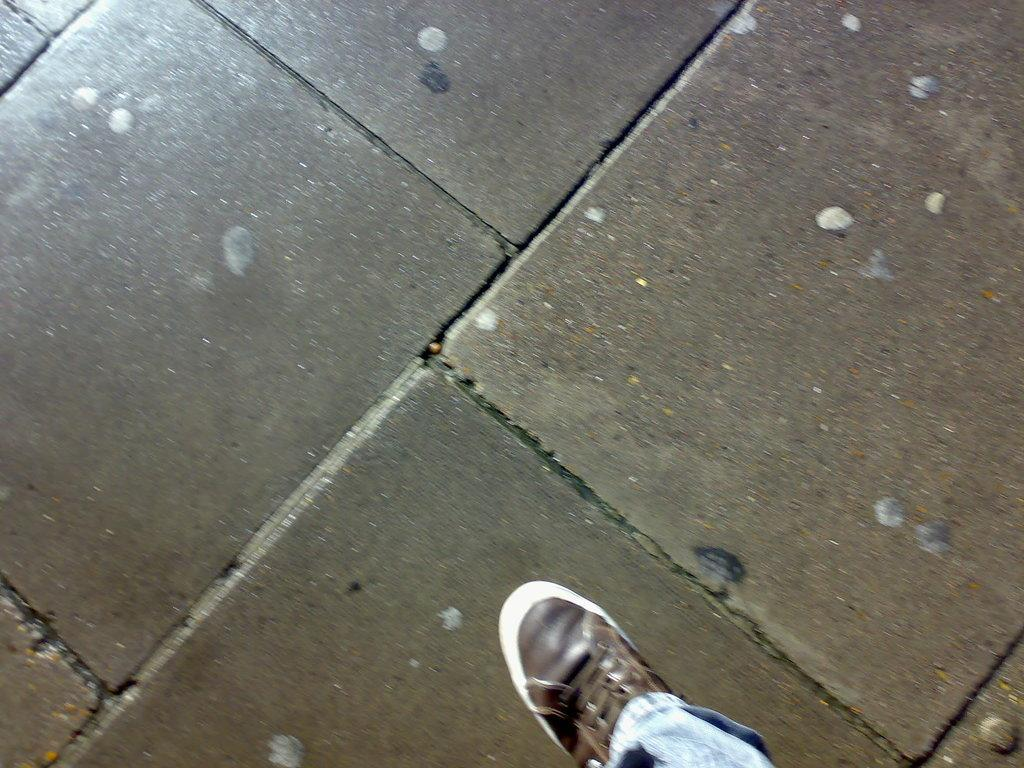What object is on the floor in the image? There is a shoe on the floor in the image. What type of park can be seen in the image? There is no park present in the image; it only features a shoe on the floor. What kind of vessel is being used in the image? There is no vessel present in the image; it only features a shoe on the floor. 